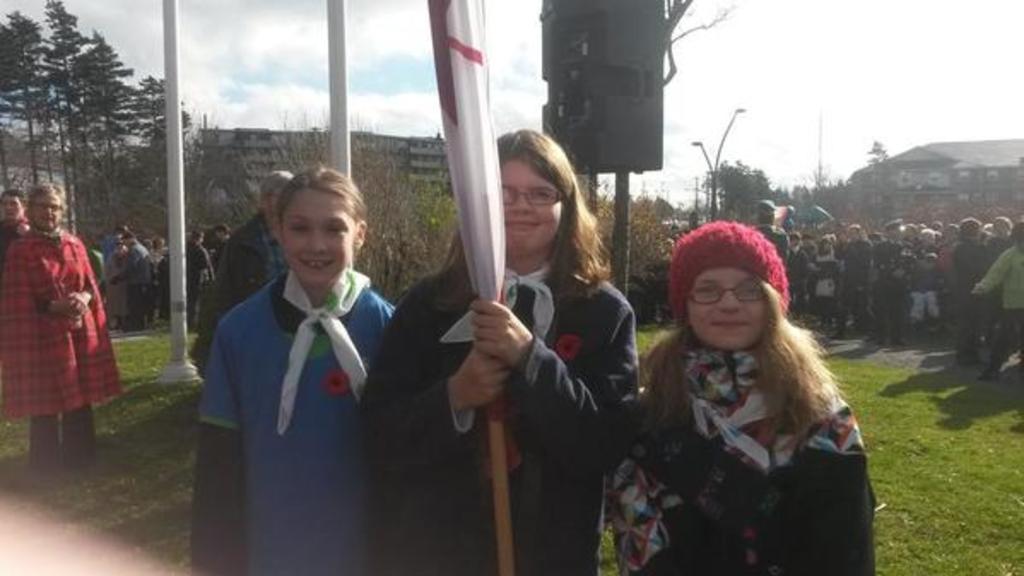Could you give a brief overview of what you see in this image? In this picture we can see three girls smiling, flag and in the background we can see a group of people standing on the ground, trees, buildings, poles, sky with clouds. 